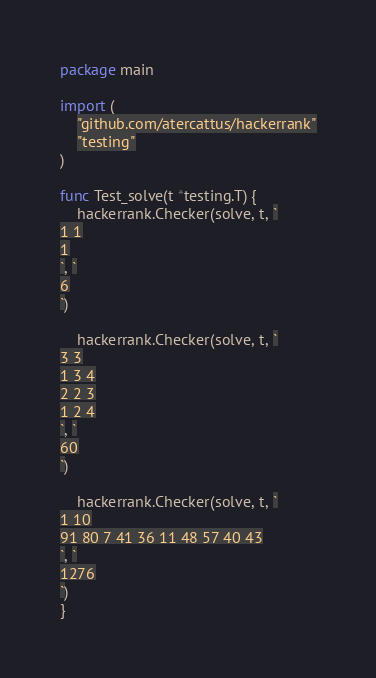<code> <loc_0><loc_0><loc_500><loc_500><_Go_>package main

import (
	"github.com/atercattus/hackerrank"
	"testing"
)

func Test_solve(t *testing.T) {
	hackerrank.Checker(solve, t, `
1 1
1
`, `
6
`)

	hackerrank.Checker(solve, t, `
3 3
1 3 4
2 2 3
1 2 4
`, `
60
`)

	hackerrank.Checker(solve, t, `
1 10
91 80 7 41 36 11 48 57 40 43
`, `
1276
`)
}
</code> 